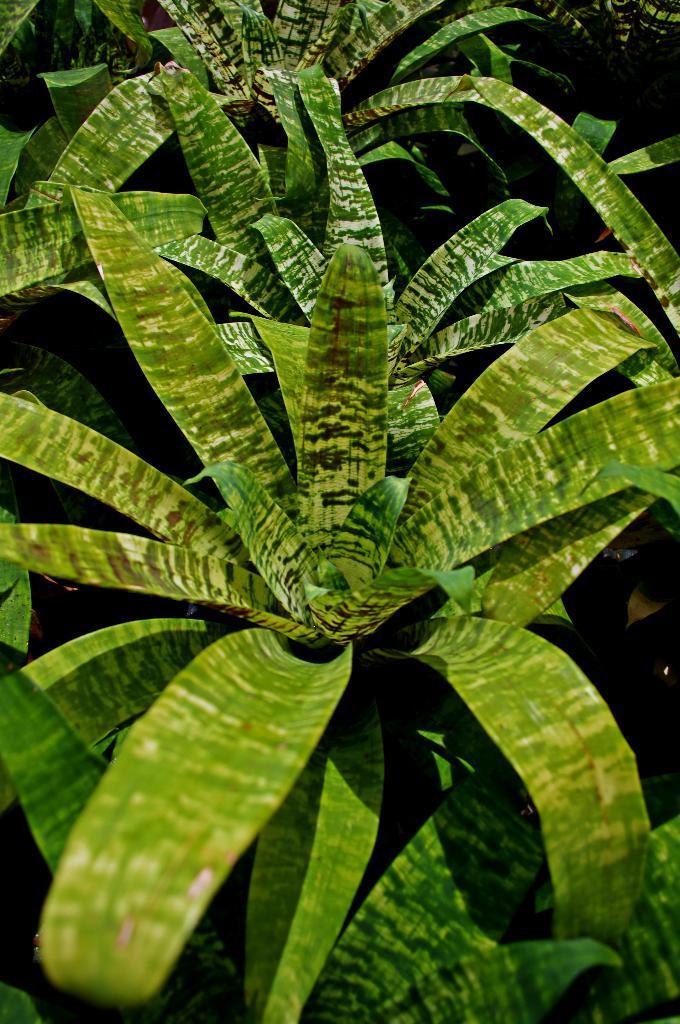Describe this image in one or two sentences. In this picture I can see number of plants and I see that it is a bit dark. 